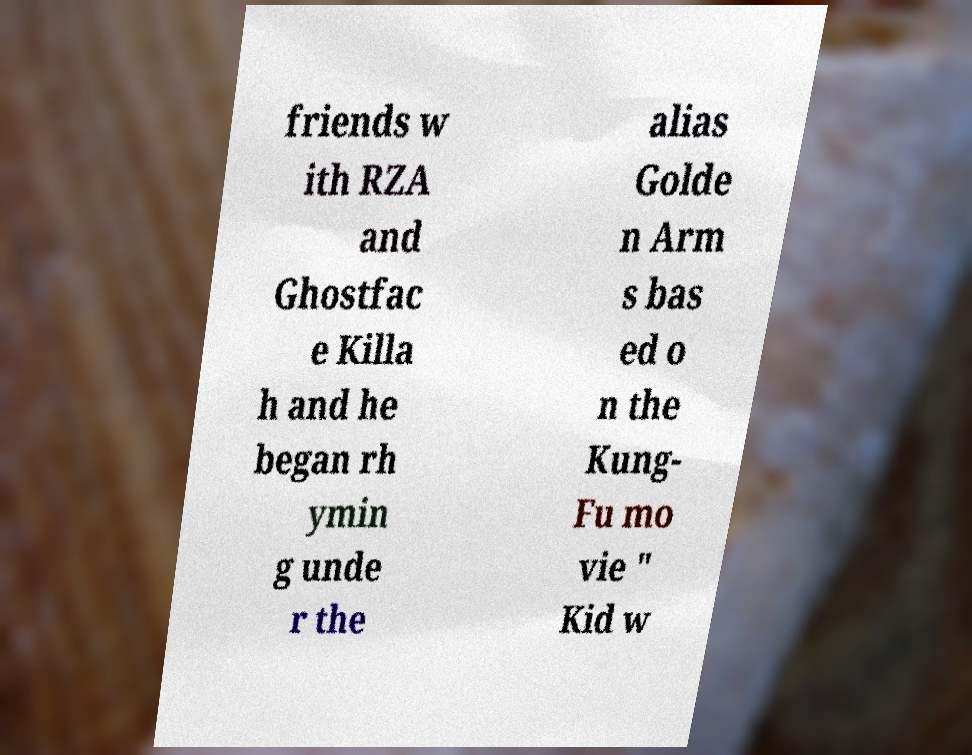Can you read and provide the text displayed in the image?This photo seems to have some interesting text. Can you extract and type it out for me? friends w ith RZA and Ghostfac e Killa h and he began rh ymin g unde r the alias Golde n Arm s bas ed o n the Kung- Fu mo vie " Kid w 